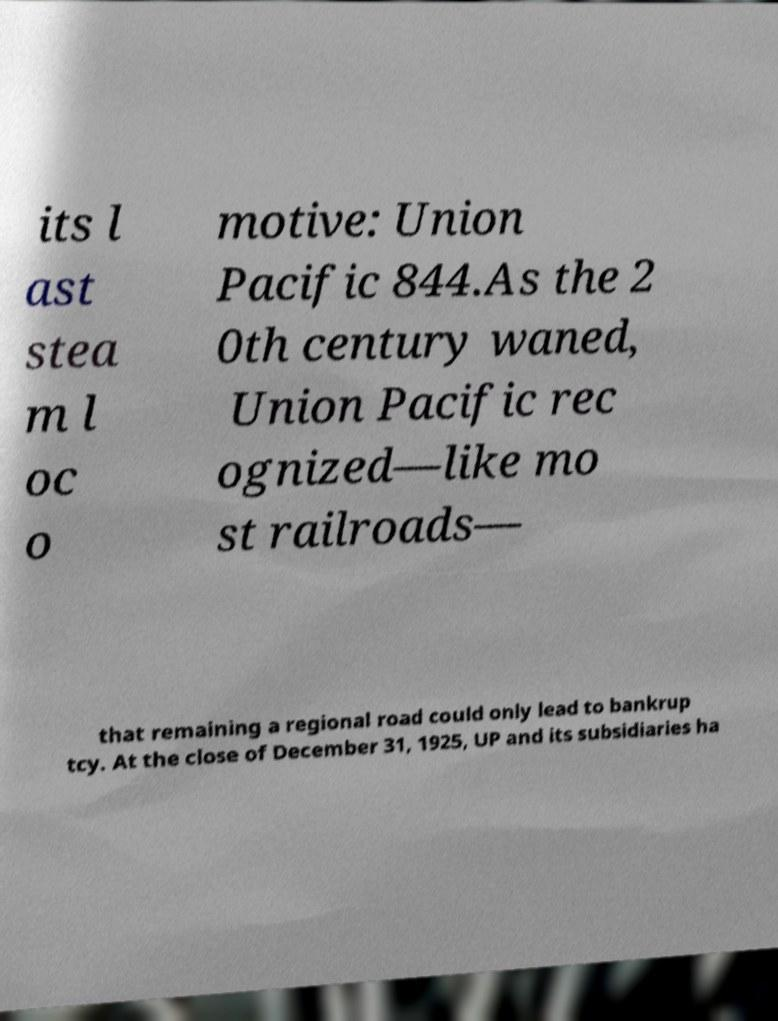Please identify and transcribe the text found in this image. its l ast stea m l oc o motive: Union Pacific 844.As the 2 0th century waned, Union Pacific rec ognized—like mo st railroads— that remaining a regional road could only lead to bankrup tcy. At the close of December 31, 1925, UP and its subsidiaries ha 